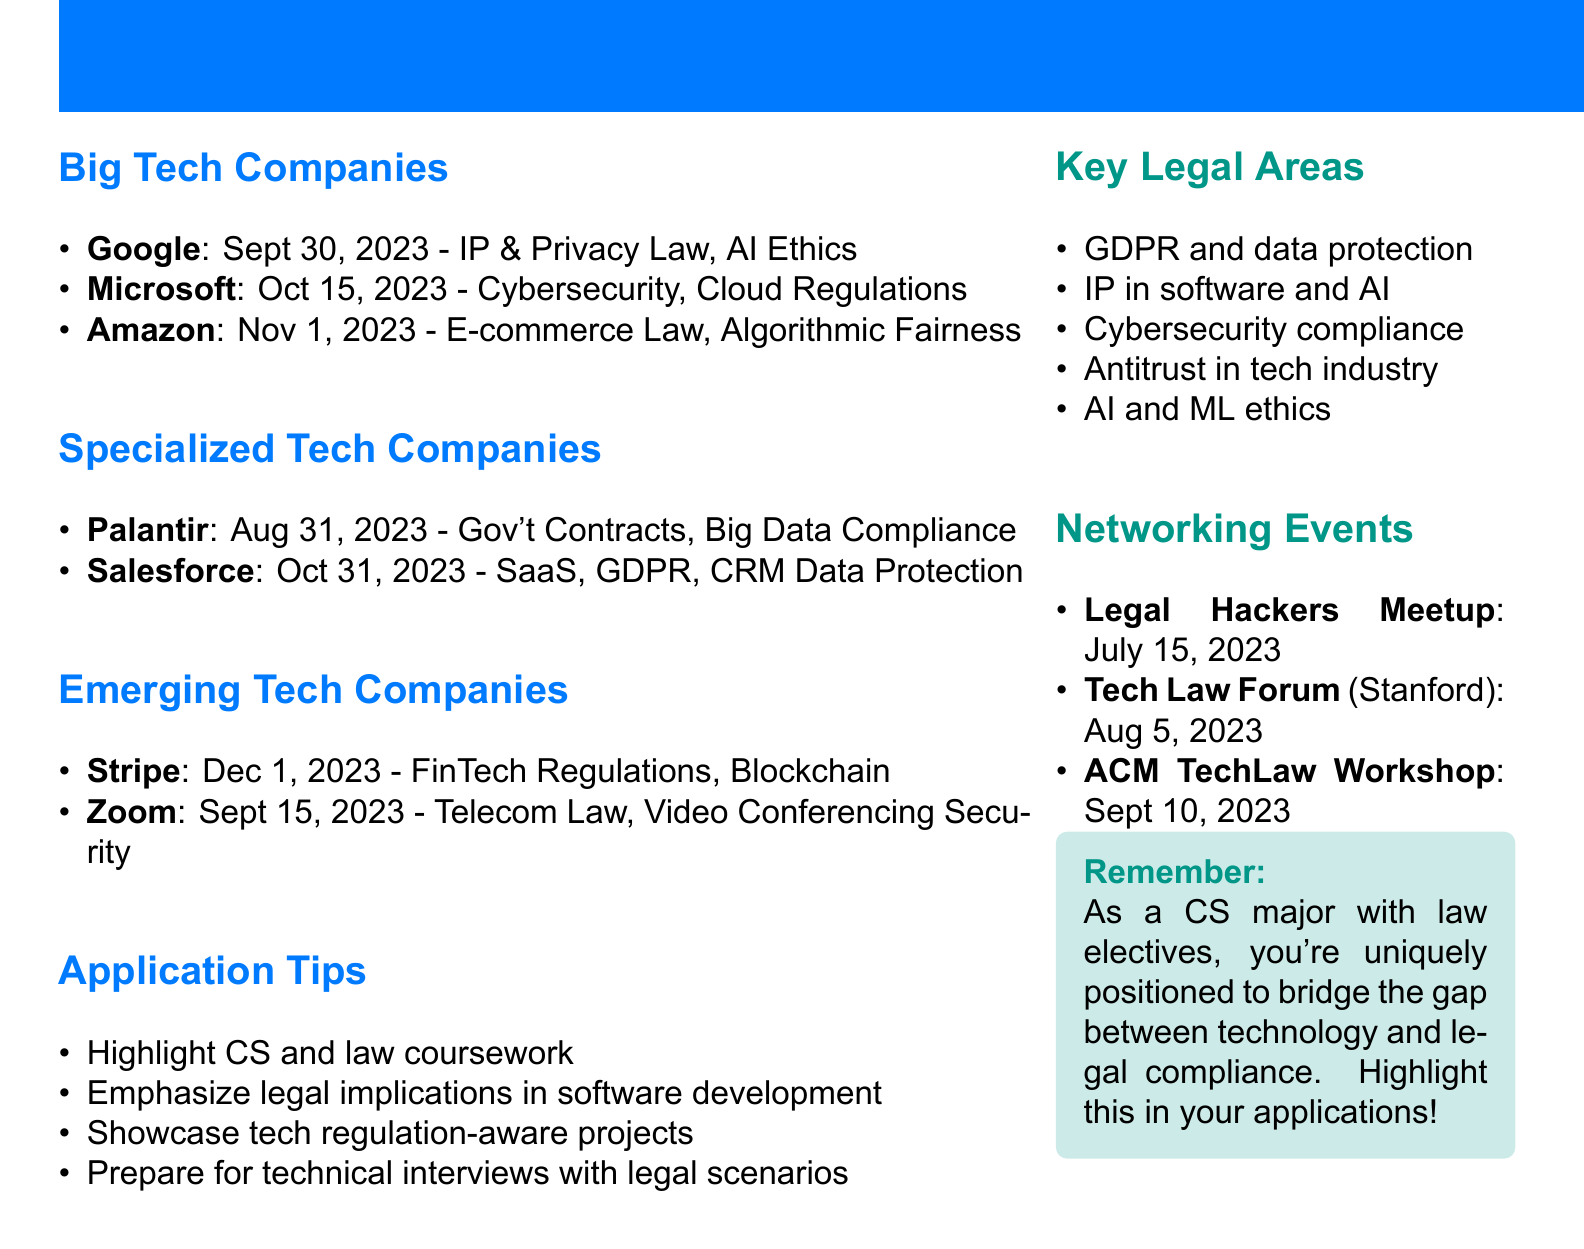What is the application deadline for Google? The application deadline for Google is specifically listed in the document under Big Tech Companies.
Answer: September 30, 2023 What legal focus does Amazon have? The legal focus for Amazon can be found in the section regarding Big Tech Companies.
Answer: E-commerce and Antitrust Law When is the application deadline for Salesforce? The application deadline for Salesforce is indicated under Specialized Tech Companies.
Answer: October 31, 2023 Which company focuses on Financial Technology Regulations? This information is available under Emerging Tech Companies section.
Answer: Stripe What is a recommended application tip? The document lists various application tips; one is highlighted as an important strategy.
Answer: Highlight coursework in both computer science and law Which event is scheduled for September 10, 2023? This question requires cross-referencing the Networking Opportunities section.
Answer: ACM TechLaw Workshop How many Big Tech Companies are listed? The total number of Big Tech Companies can be counted from the relevant section.
Answer: Three What key legal area is related to AI and software? The document indicates several key legal areas; one specifically addresses concerns with AI.
Answer: Intellectual property in software and AI What is one aspect of legal relevance for Stripe? The legal relevance associated with Stripe is explicitly stated in the Emerging Tech Companies section.
Answer: Secure Payment Systems and Blockchain 